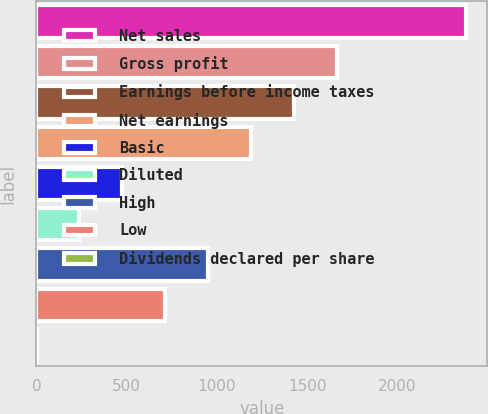Convert chart. <chart><loc_0><loc_0><loc_500><loc_500><bar_chart><fcel>Net sales<fcel>Gross profit<fcel>Earnings before income taxes<fcel>Net earnings<fcel>Basic<fcel>Diluted<fcel>High<fcel>Low<fcel>Dividends declared per share<nl><fcel>2379<fcel>1665.43<fcel>1427.56<fcel>1189.69<fcel>476.08<fcel>238.21<fcel>951.82<fcel>713.95<fcel>0.34<nl></chart> 